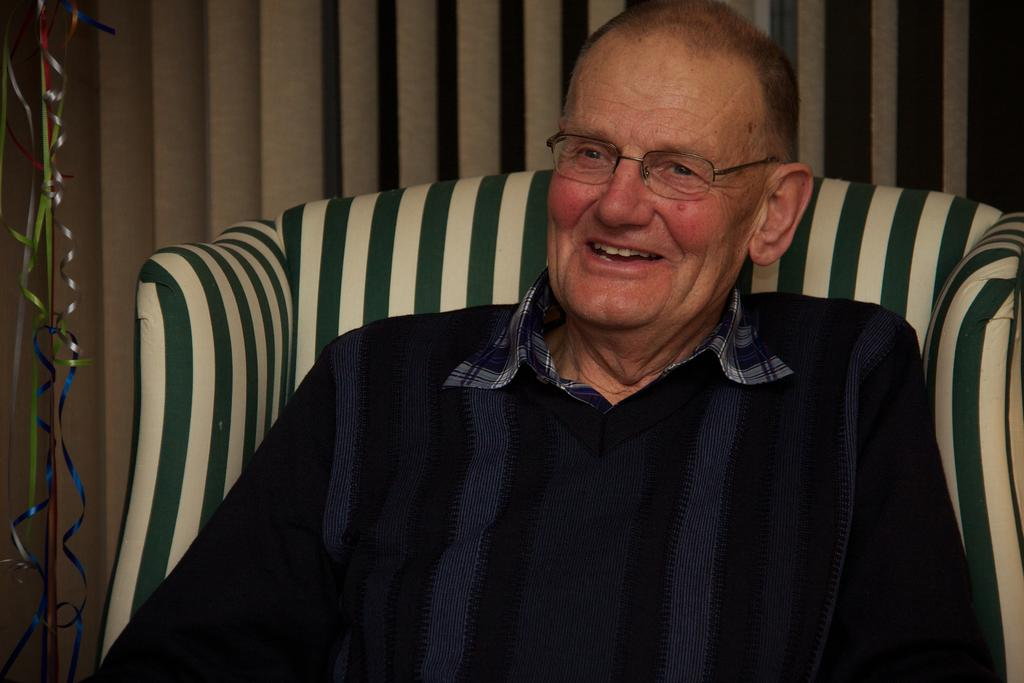What is the man in the image doing? The man is sitting in the image. What expression does the man have? The man is smiling. What piece of furniture is present in the image? There is a couch in the image. What is partially visible towards the left of the image? There is an object truncated towards the left of the image. What can be seen behind the man in the image? There is a wall in the image. What type of lunch is the man eating in the image? There is no lunch present in the image, as the man is not eating anything. 